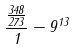Convert formula to latex. <formula><loc_0><loc_0><loc_500><loc_500>\frac { \frac { 3 4 8 } { 2 7 3 } } { 1 } - 9 ^ { 1 3 }</formula> 